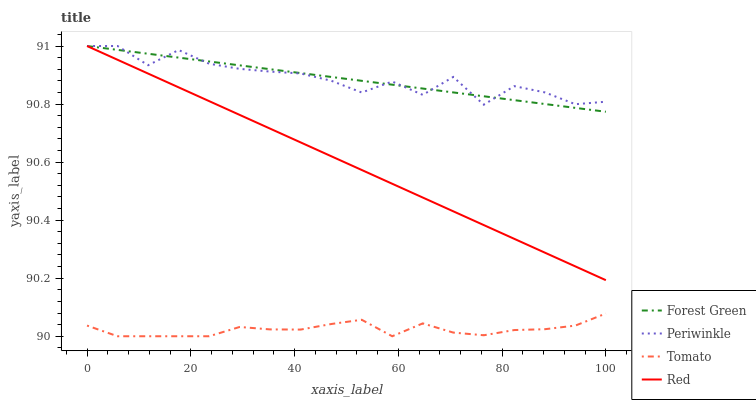Does Forest Green have the minimum area under the curve?
Answer yes or no. No. Does Forest Green have the maximum area under the curve?
Answer yes or no. No. Is Periwinkle the smoothest?
Answer yes or no. No. Is Forest Green the roughest?
Answer yes or no. No. Does Forest Green have the lowest value?
Answer yes or no. No. Is Tomato less than Periwinkle?
Answer yes or no. Yes. Is Red greater than Tomato?
Answer yes or no. Yes. Does Tomato intersect Periwinkle?
Answer yes or no. No. 